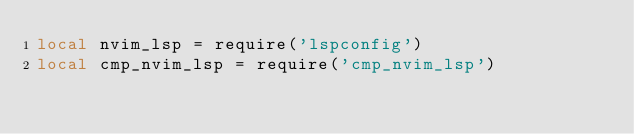Convert code to text. <code><loc_0><loc_0><loc_500><loc_500><_Lua_>local nvim_lsp = require('lspconfig')
local cmp_nvim_lsp = require('cmp_nvim_lsp')</code> 